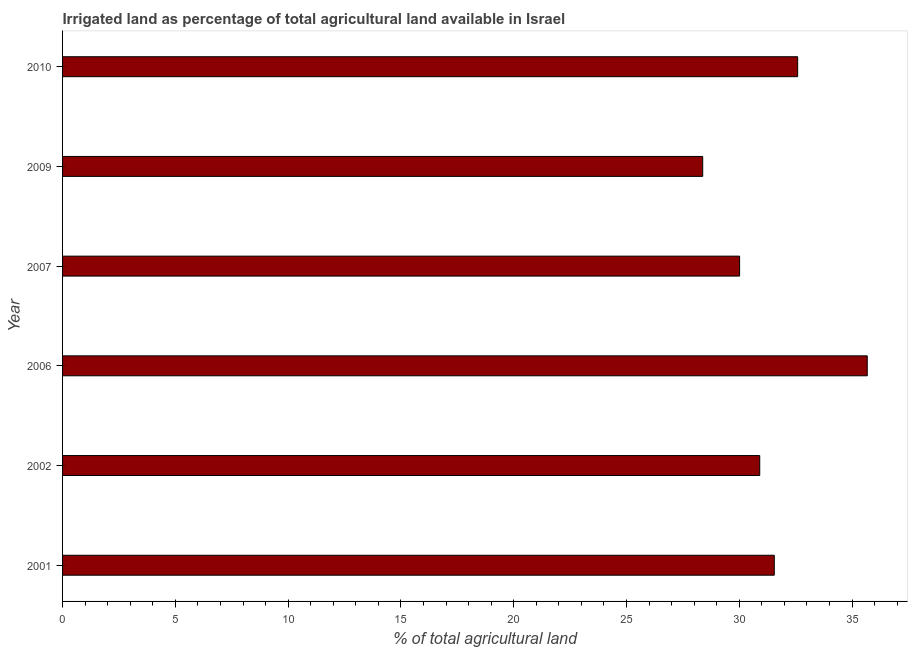Does the graph contain any zero values?
Ensure brevity in your answer.  No. What is the title of the graph?
Keep it short and to the point. Irrigated land as percentage of total agricultural land available in Israel. What is the label or title of the X-axis?
Offer a very short reply. % of total agricultural land. What is the label or title of the Y-axis?
Provide a succinct answer. Year. What is the percentage of agricultural irrigated land in 2006?
Make the answer very short. 35.67. Across all years, what is the maximum percentage of agricultural irrigated land?
Give a very brief answer. 35.67. Across all years, what is the minimum percentage of agricultural irrigated land?
Your response must be concise. 28.38. In which year was the percentage of agricultural irrigated land maximum?
Ensure brevity in your answer.  2006. What is the sum of the percentage of agricultural irrigated land?
Your answer should be compact. 189.11. What is the difference between the percentage of agricultural irrigated land in 2002 and 2009?
Offer a terse response. 2.53. What is the average percentage of agricultural irrigated land per year?
Your response must be concise. 31.52. What is the median percentage of agricultural irrigated land?
Your answer should be compact. 31.23. Do a majority of the years between 2002 and 2006 (inclusive) have percentage of agricultural irrigated land greater than 25 %?
Offer a very short reply. Yes. What is the ratio of the percentage of agricultural irrigated land in 2002 to that in 2006?
Your answer should be very brief. 0.87. Is the percentage of agricultural irrigated land in 2001 less than that in 2002?
Give a very brief answer. No. Is the difference between the percentage of agricultural irrigated land in 2002 and 2010 greater than the difference between any two years?
Provide a short and direct response. No. What is the difference between the highest and the second highest percentage of agricultural irrigated land?
Provide a succinct answer. 3.08. What is the difference between the highest and the lowest percentage of agricultural irrigated land?
Keep it short and to the point. 7.29. How many bars are there?
Your answer should be compact. 6. Are all the bars in the graph horizontal?
Make the answer very short. Yes. How many years are there in the graph?
Keep it short and to the point. 6. Are the values on the major ticks of X-axis written in scientific E-notation?
Provide a short and direct response. No. What is the % of total agricultural land in 2001?
Ensure brevity in your answer.  31.55. What is the % of total agricultural land in 2002?
Offer a very short reply. 30.91. What is the % of total agricultural land in 2006?
Your response must be concise. 35.67. What is the % of total agricultural land of 2007?
Provide a short and direct response. 30.01. What is the % of total agricultural land in 2009?
Your response must be concise. 28.38. What is the % of total agricultural land of 2010?
Your answer should be compact. 32.59. What is the difference between the % of total agricultural land in 2001 and 2002?
Your answer should be compact. 0.64. What is the difference between the % of total agricultural land in 2001 and 2006?
Ensure brevity in your answer.  -4.12. What is the difference between the % of total agricultural land in 2001 and 2007?
Ensure brevity in your answer.  1.54. What is the difference between the % of total agricultural land in 2001 and 2009?
Your answer should be compact. 3.17. What is the difference between the % of total agricultural land in 2001 and 2010?
Keep it short and to the point. -1.04. What is the difference between the % of total agricultural land in 2002 and 2006?
Keep it short and to the point. -4.77. What is the difference between the % of total agricultural land in 2002 and 2007?
Your answer should be very brief. 0.89. What is the difference between the % of total agricultural land in 2002 and 2009?
Ensure brevity in your answer.  2.53. What is the difference between the % of total agricultural land in 2002 and 2010?
Keep it short and to the point. -1.68. What is the difference between the % of total agricultural land in 2006 and 2007?
Provide a short and direct response. 5.66. What is the difference between the % of total agricultural land in 2006 and 2009?
Keep it short and to the point. 7.29. What is the difference between the % of total agricultural land in 2006 and 2010?
Make the answer very short. 3.09. What is the difference between the % of total agricultural land in 2007 and 2009?
Provide a succinct answer. 1.64. What is the difference between the % of total agricultural land in 2007 and 2010?
Your answer should be compact. -2.57. What is the difference between the % of total agricultural land in 2009 and 2010?
Your response must be concise. -4.21. What is the ratio of the % of total agricultural land in 2001 to that in 2002?
Make the answer very short. 1.02. What is the ratio of the % of total agricultural land in 2001 to that in 2006?
Your response must be concise. 0.88. What is the ratio of the % of total agricultural land in 2001 to that in 2007?
Your answer should be very brief. 1.05. What is the ratio of the % of total agricultural land in 2001 to that in 2009?
Offer a terse response. 1.11. What is the ratio of the % of total agricultural land in 2001 to that in 2010?
Offer a very short reply. 0.97. What is the ratio of the % of total agricultural land in 2002 to that in 2006?
Give a very brief answer. 0.87. What is the ratio of the % of total agricultural land in 2002 to that in 2007?
Keep it short and to the point. 1.03. What is the ratio of the % of total agricultural land in 2002 to that in 2009?
Your response must be concise. 1.09. What is the ratio of the % of total agricultural land in 2002 to that in 2010?
Offer a terse response. 0.95. What is the ratio of the % of total agricultural land in 2006 to that in 2007?
Give a very brief answer. 1.19. What is the ratio of the % of total agricultural land in 2006 to that in 2009?
Offer a terse response. 1.26. What is the ratio of the % of total agricultural land in 2006 to that in 2010?
Provide a short and direct response. 1.09. What is the ratio of the % of total agricultural land in 2007 to that in 2009?
Offer a terse response. 1.06. What is the ratio of the % of total agricultural land in 2007 to that in 2010?
Provide a short and direct response. 0.92. What is the ratio of the % of total agricultural land in 2009 to that in 2010?
Your response must be concise. 0.87. 